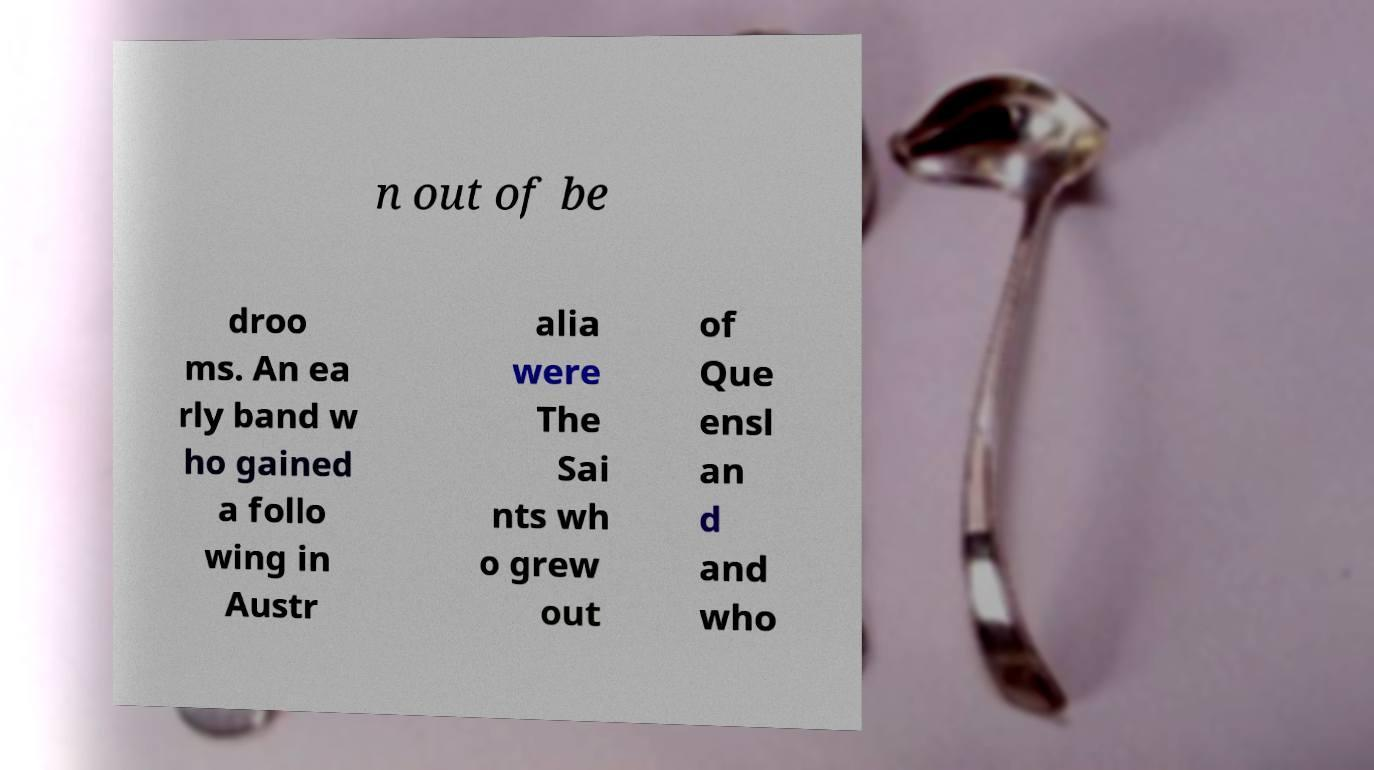Could you extract and type out the text from this image? n out of be droo ms. An ea rly band w ho gained a follo wing in Austr alia were The Sai nts wh o grew out of Que ensl an d and who 